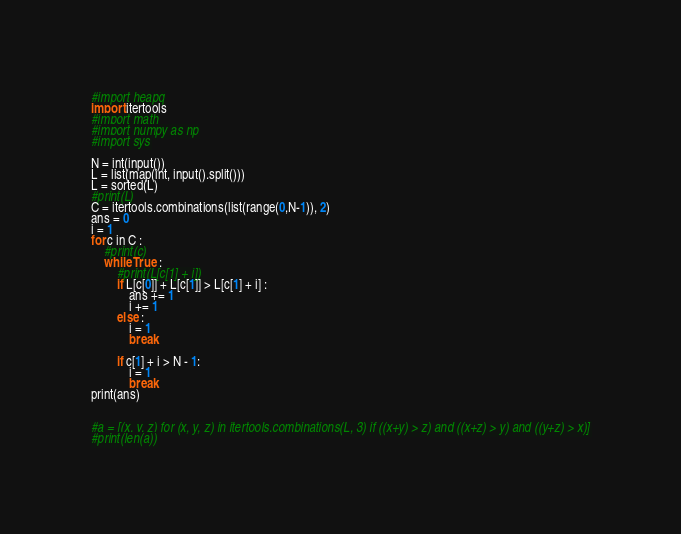Convert code to text. <code><loc_0><loc_0><loc_500><loc_500><_Python_>#import heapq
import itertools
#import math
#import numpy as np
#import sys

N = int(input())
L = list(map(int, input().split()))
L = sorted(L)
#print(L)
C = itertools.combinations(list(range(0,N-1)), 2)
ans = 0
i = 1
for c in C :
    #print(c)
    while True :
        #print(L[c[1] + i])
        if L[c[0]] + L[c[1]] > L[c[1] + i] :
            ans += 1
            i += 1
        else :
            i = 1
            break

        if c[1] + i > N - 1:
            i = 1
            break
print(ans)


#a = [(x, y, z) for (x, y, z) in itertools.combinations(L, 3) if ((x+y) > z) and ((x+z) > y) and ((y+z) > x)]
#print(len(a))</code> 